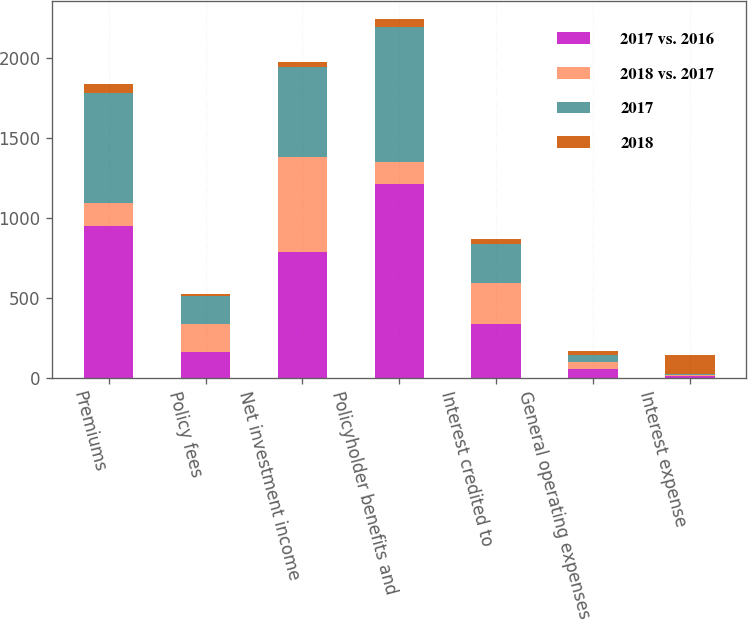Convert chart. <chart><loc_0><loc_0><loc_500><loc_500><stacked_bar_chart><ecel><fcel>Premiums<fcel>Policy fees<fcel>Net investment income<fcel>Policyholder benefits and<fcel>Interest credited to<fcel>General operating expenses<fcel>Interest expense<nl><fcel>2017 vs. 2016<fcel>952<fcel>161<fcel>786<fcel>1214<fcel>338<fcel>56<fcel>13<nl><fcel>2018 vs. 2017<fcel>139<fcel>174<fcel>595<fcel>139<fcel>253<fcel>44<fcel>6<nl><fcel>2017<fcel>691<fcel>179<fcel>563<fcel>843<fcel>244<fcel>41<fcel>4<nl><fcel>2018<fcel>60<fcel>7<fcel>32<fcel>53<fcel>34<fcel>27<fcel>117<nl></chart> 